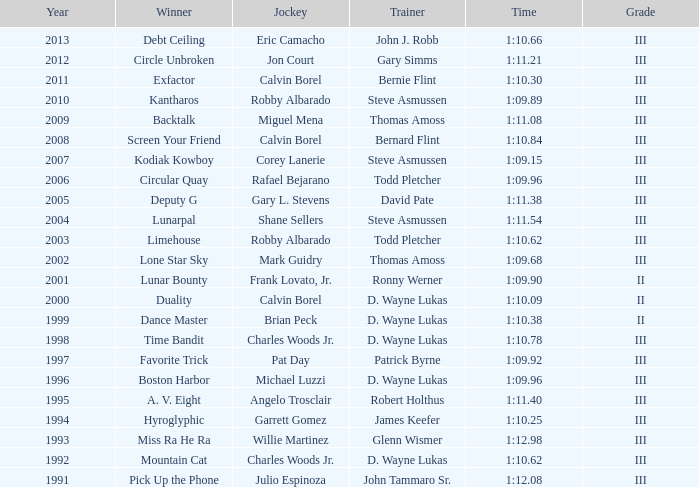Who won under Gary Simms? Circle Unbroken. 